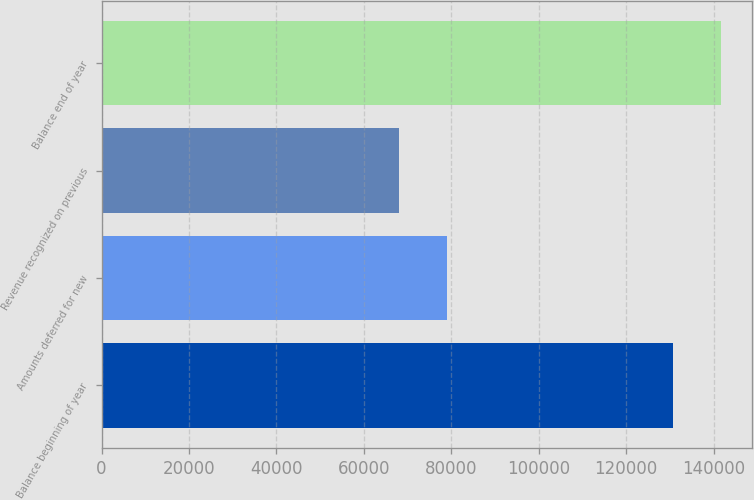<chart> <loc_0><loc_0><loc_500><loc_500><bar_chart><fcel>Balance beginning of year<fcel>Amounts deferred for new<fcel>Revenue recognized on previous<fcel>Balance end of year<nl><fcel>130762<fcel>78900<fcel>67978<fcel>141684<nl></chart> 